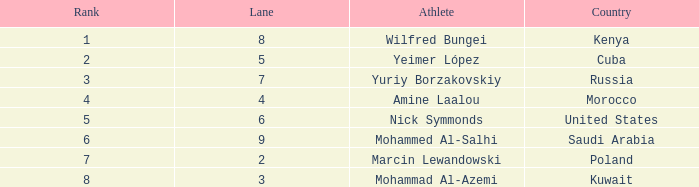What is the Rank of the Athlete with a Time of 1:47.65 and in Lane 3 or larger? None. 